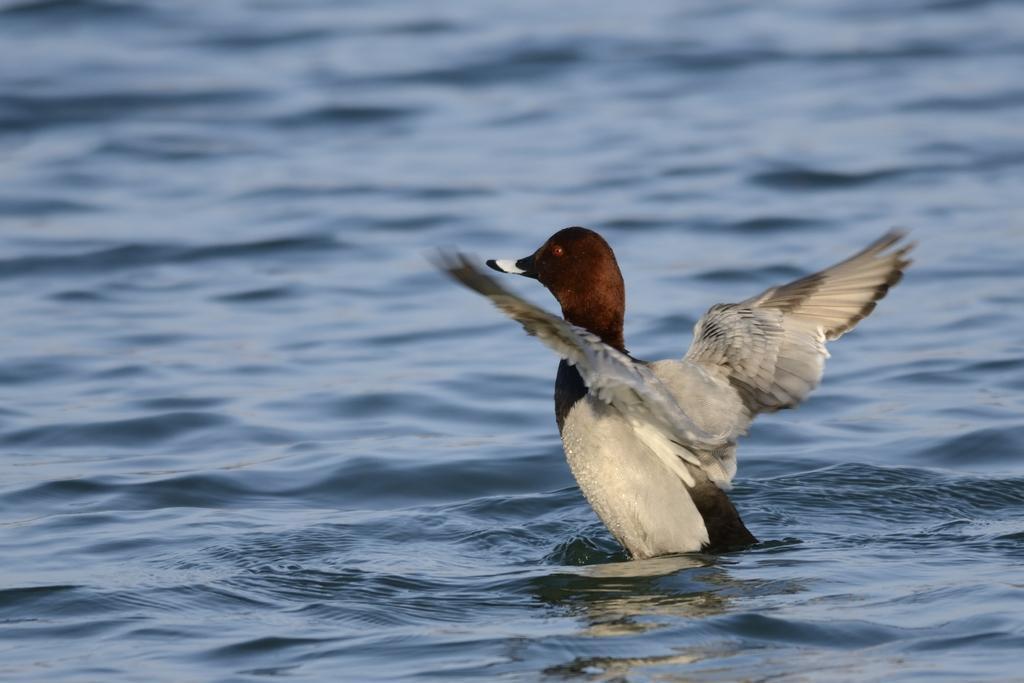Could you give a brief overview of what you see in this image? In this picture I can see the bird on the right side. I can see water. 